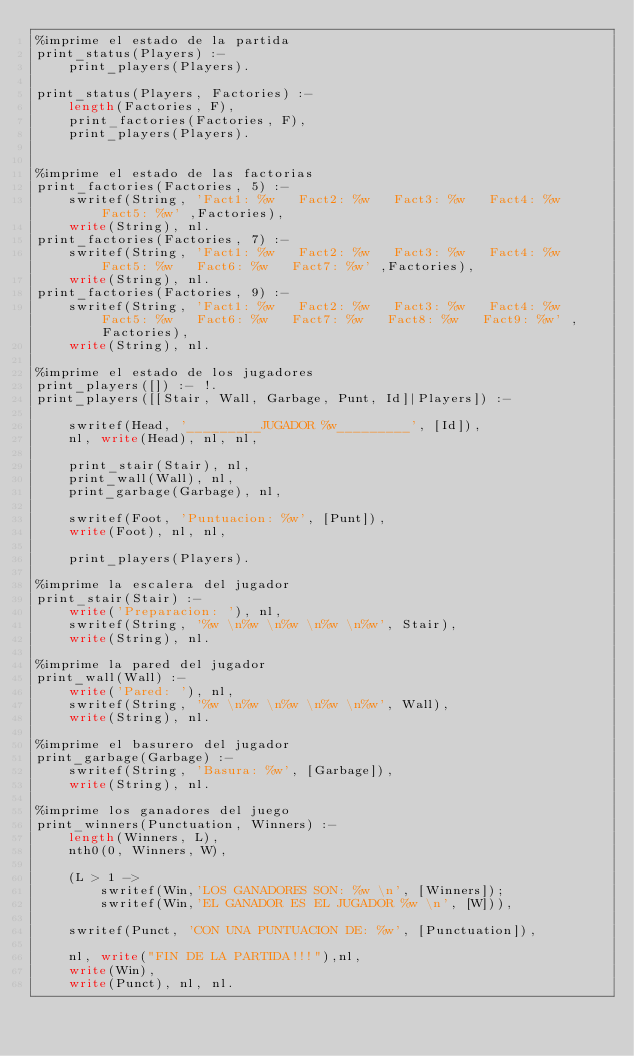<code> <loc_0><loc_0><loc_500><loc_500><_Perl_>%imprime el estado de la partida
print_status(Players) :-
    print_players(Players).

print_status(Players, Factories) :- 
    length(Factories, F),
    print_factories(Factories, F),
    print_players(Players).


%imprime el estado de las factorias
print_factories(Factories, 5) :-
    swritef(String, 'Fact1: %w   Fact2: %w   Fact3: %w   Fact4: %w   Fact5: %w' ,Factories),
    write(String), nl.
print_factories(Factories, 7) :-
    swritef(String, 'Fact1: %w   Fact2: %w   Fact3: %w   Fact4: %w   Fact5: %w   Fact6: %w   Fact7: %w' ,Factories),
    write(String), nl.
print_factories(Factories, 9) :-
    swritef(String, 'Fact1: %w   Fact2: %w   Fact3: %w   Fact4: %w   Fact5: %w   Fact6: %w   Fact7: %w   Fact8: %w   Fact9: %w' ,Factories),
    write(String), nl.
    
%imprime el estado de los jugadores
print_players([]) :- !.
print_players([[Stair, Wall, Garbage, Punt, Id]|Players]) :- 

    swritef(Head, '_________JUGADOR %w_________', [Id]),
    nl, write(Head), nl, nl,

    print_stair(Stair), nl,
    print_wall(Wall), nl,
    print_garbage(Garbage), nl,
 
    swritef(Foot, 'Puntuacion: %w', [Punt]),
    write(Foot), nl, nl,
    
    print_players(Players).

%imprime la escalera del jugador
print_stair(Stair) :- 
    write('Preparacion: '), nl,
    swritef(String, '%w \n%w \n%w \n%w \n%w', Stair),
    write(String), nl.

%imprime la pared del jugador
print_wall(Wall) :- 
    write('Pared: '), nl,
    swritef(String, '%w \n%w \n%w \n%w \n%w', Wall),
    write(String), nl.

%imprime el basurero del jugador
print_garbage(Garbage) :-
    swritef(String, 'Basura: %w', [Garbage]),
    write(String), nl.

%imprime los ganadores del juego
print_winners(Punctuation, Winners) :- 
    length(Winners, L),
    nth0(0, Winners, W),

    (L > 1 -> 
        swritef(Win,'LOS GANADORES SON: %w \n', [Winners]); 
        swritef(Win,'EL GANADOR ES EL JUGADOR %w \n', [W])),

    swritef(Punct, 'CON UNA PUNTUACION DE: %w', [Punctuation]),
    
    nl, write("FIN DE LA PARTIDA!!!"),nl,
    write(Win), 
    write(Punct), nl, nl.</code> 